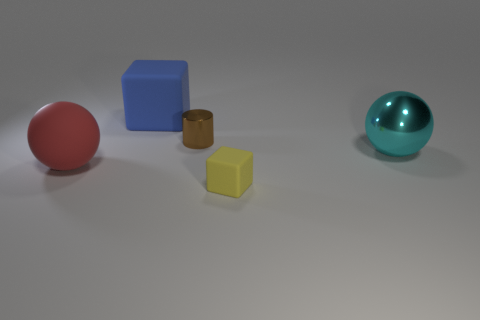There is a blue matte thing; how many large things are on the right side of it?
Offer a very short reply. 1. There is a big matte object in front of the big ball right of the sphere left of the large blue object; what color is it?
Provide a short and direct response. Red. There is a big matte thing right of the red ball; does it have the same color as the sphere that is on the left side of the tiny brown metallic cylinder?
Offer a terse response. No. There is a yellow thing in front of the large rubber object behind the brown metal cylinder; what shape is it?
Ensure brevity in your answer.  Cube. Is there a red matte sphere that has the same size as the blue thing?
Make the answer very short. Yes. How many big cyan metallic objects are the same shape as the tiny yellow thing?
Make the answer very short. 0. Is the number of small shiny cylinders in front of the big rubber ball the same as the number of tiny yellow rubber objects behind the big rubber cube?
Your response must be concise. Yes. Are any small yellow rubber things visible?
Ensure brevity in your answer.  Yes. There is a ball that is left of the rubber cube that is in front of the sphere on the right side of the tiny brown cylinder; what is its size?
Your answer should be very brief. Large. The blue matte object that is the same size as the cyan ball is what shape?
Give a very brief answer. Cube. 